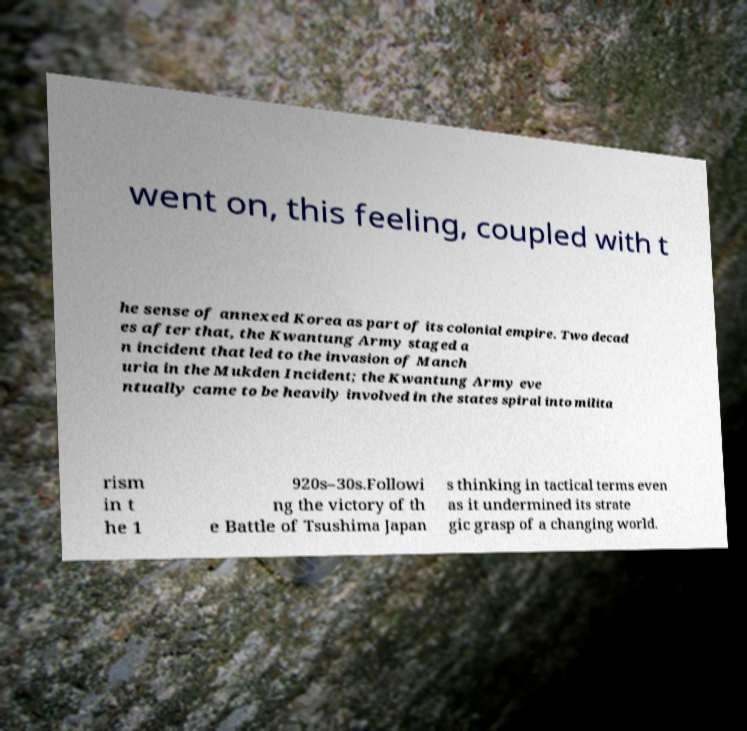There's text embedded in this image that I need extracted. Can you transcribe it verbatim? went on, this feeling, coupled with t he sense of annexed Korea as part of its colonial empire. Two decad es after that, the Kwantung Army staged a n incident that led to the invasion of Manch uria in the Mukden Incident; the Kwantung Army eve ntually came to be heavily involved in the states spiral into milita rism in t he 1 920s–30s.Followi ng the victory of th e Battle of Tsushima Japan s thinking in tactical terms even as it undermined its strate gic grasp of a changing world. 